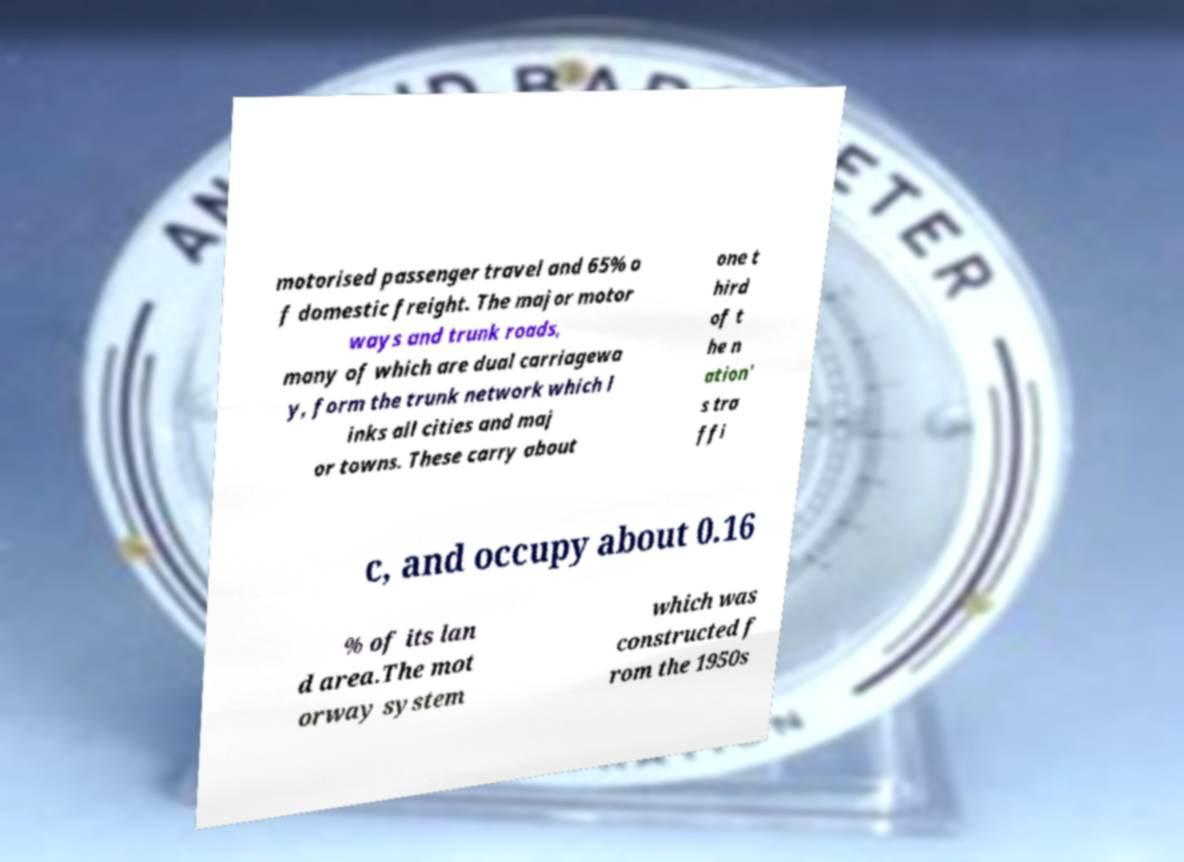Can you read and provide the text displayed in the image?This photo seems to have some interesting text. Can you extract and type it out for me? motorised passenger travel and 65% o f domestic freight. The major motor ways and trunk roads, many of which are dual carriagewa y, form the trunk network which l inks all cities and maj or towns. These carry about one t hird of t he n ation' s tra ffi c, and occupy about 0.16 % of its lan d area.The mot orway system which was constructed f rom the 1950s 